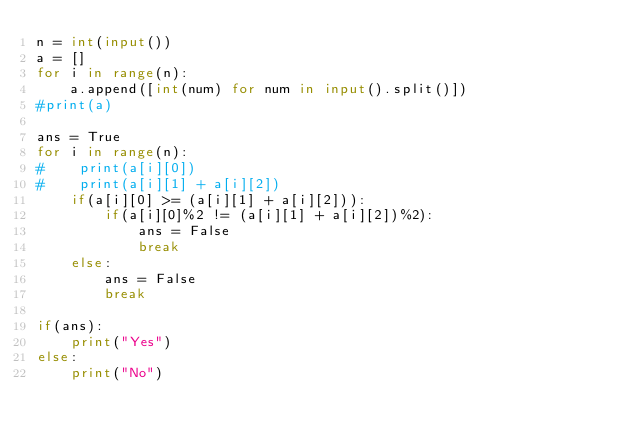Convert code to text. <code><loc_0><loc_0><loc_500><loc_500><_Python_>n = int(input())
a = []
for i in range(n):
    a.append([int(num) for num in input().split()])
#print(a)

ans = True
for i in range(n):
#    print(a[i][0])
#    print(a[i][1] + a[i][2])
    if(a[i][0] >= (a[i][1] + a[i][2])):
        if(a[i][0]%2 != (a[i][1] + a[i][2])%2):
            ans = False
            break
    else:
        ans = False
        break
    
if(ans):
    print("Yes")
else:
    print("No")
</code> 